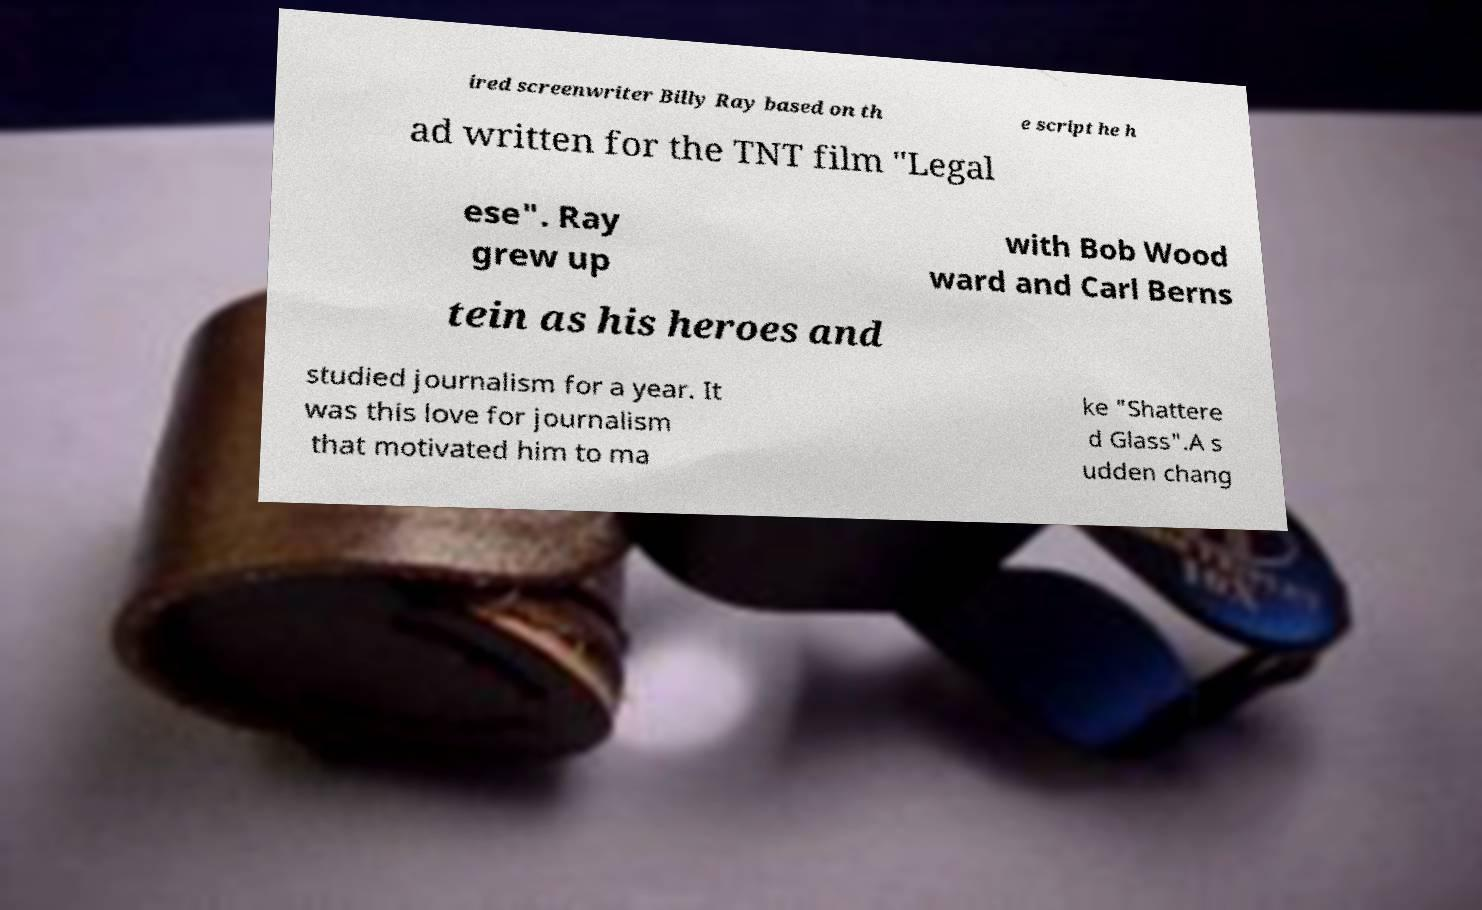Could you extract and type out the text from this image? ired screenwriter Billy Ray based on th e script he h ad written for the TNT film "Legal ese". Ray grew up with Bob Wood ward and Carl Berns tein as his heroes and studied journalism for a year. It was this love for journalism that motivated him to ma ke "Shattere d Glass".A s udden chang 